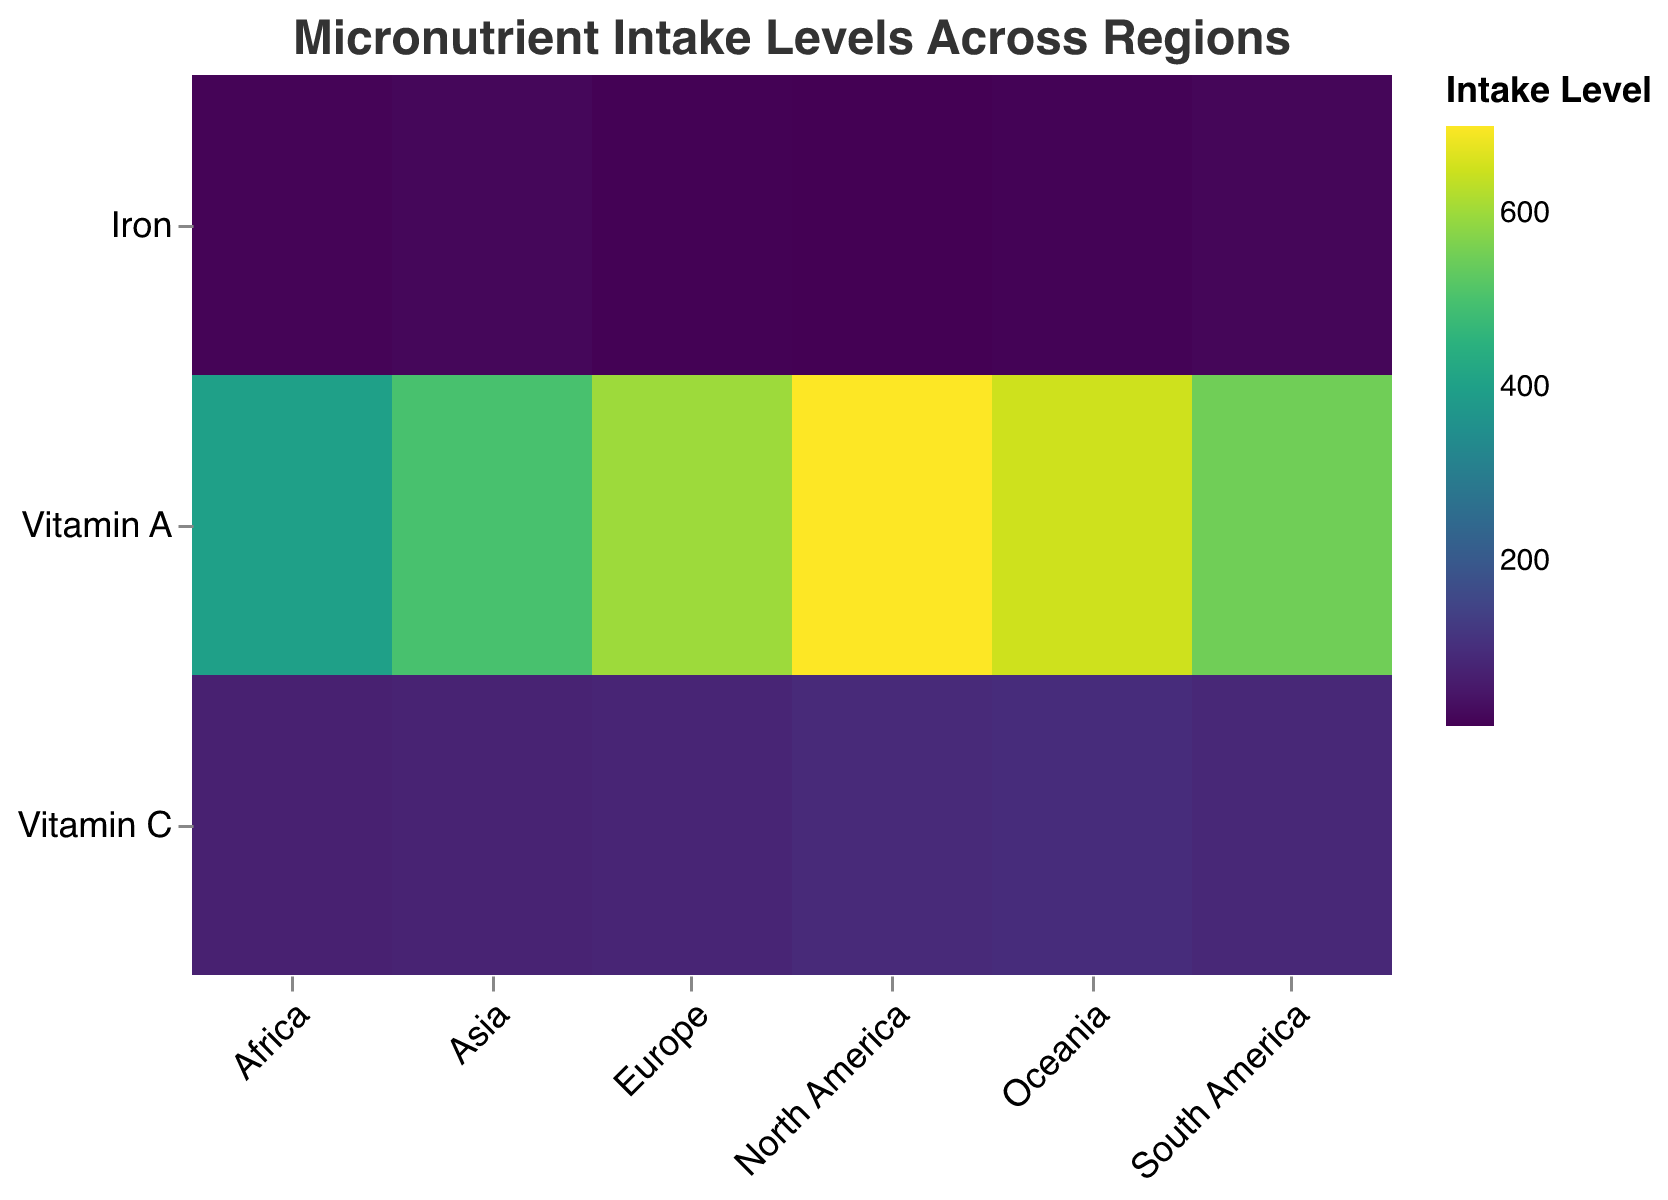What is the intake level of Vitamin C in North America? Look for the Vitamin C row and check the value within the North America column. The intake level for Vitamin C in North America is 90 mg/day.
Answer: 90 mg/day Which region has the highest intake level of Iron? Compare the Iron intake levels for each region. The highest value is 20 mg/day in Asia.
Answer: Asia Compare the intake levels of Vitamin A between Europe and Africa. Examine the Vitamin A intake levels for both Europe and Africa. Europe has 600 ug/day, while Africa has 400 ug/day.
Answer: Europe has higher intake levels of Vitamin A than Africa What is the difference in Vitamin C intake levels between Oceania and South America? Subtract the intake level of Vitamin C in South America (85 mg/day) from that in Oceania (95 mg/day). The difference is 95 - 85 = 10 mg/day.
Answer: 10 mg/day Which micronutrient has the lowest intake level in Africa? Find the minimum value among the intake levels for Vitamin A, Vitamin C, and Iron in Africa. Vitamin A is 400 ug/day, Vitamin C is 70 mg/day, and Iron is 15 mg/day. Iron has the lowest intake level.
Answer: Iron Summarize the intake levels of Vitamin A across all regions. List the intake levels of Vitamin A for all regions: North America (700 ug/day), Europe (600 ug/day), Asia (500 ug/day), Africa (400 ug/day), South America (550 ug/day), Oceania (650 ug/day).
Answer: North America: 700, Europe: 600, Asia: 500, Africa: 400, South America: 550, Oceania: 650 Is there any region where the intake level of Vitamin C is higher than that of Iron by more than 80 mg/day? Calculate the difference between Vitamin C and Iron intake levels for each region. In North America (90-10=80 mg/day), Europe (80-12=68 mg/day), Asia (75-20=55 mg/day), Africa (70-15=55 mg/day), South America (85-18=67 mg/day), and Oceania (95-13=82 mg/day). In Oceania, the difference of 82 mg/day is more than 80 mg/day.
Answer: Yes, in Oceania Which region has the most balanced intake levels of Iron and Vitamin C? Define "most balanced" as the smallest difference between Iron and Vitamin C intake levels. Check the differences for each region: North America (80 mg/day), Europe (68 mg/day), Asia (55 mg/day), Africa (55 mg/day), South America (67 mg/day), Oceania (82 mg/day). Both Asia and Africa have the smallest difference of 55 mg/day.
Answer: Asia, Africa What is the average intake level of Iron across all regions? Sum the Iron intake levels for all regions and divide by the number of regions. (10 + 12 + 20 + 15 + 18 + 13) / 6 = 88 / 6 = 14.67 mg/day.
Answer: 14.67 mg/day 